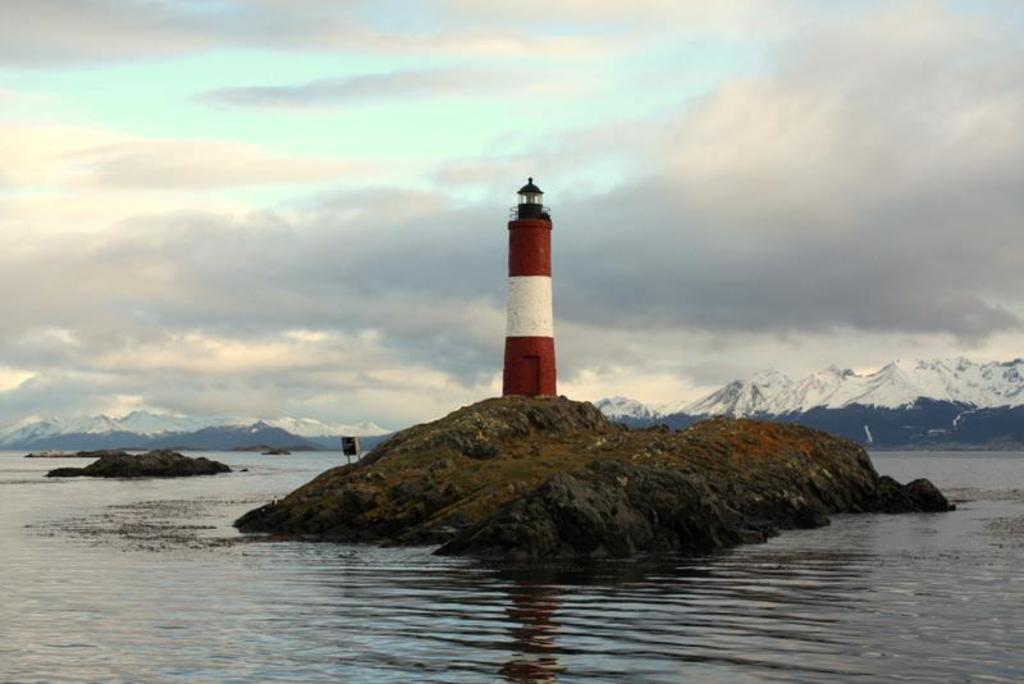What structure is located on the rock in the image? There is a lighthouse on a rock in the image. What can be seen surrounding the lighthouse? There is water visible in the image. What type of landscape can be seen in the background of the image? There are mountains in the background of the image. What is visible in the sky in the image? The sky is visible in the background of the image, and clouds are present. What is the temperature of the water in the image? The temperature of the water cannot be determined from the image, as it does not provide any information about the temperature. 